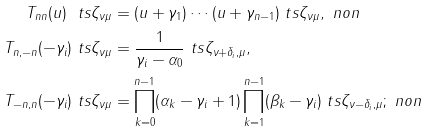Convert formula to latex. <formula><loc_0><loc_0><loc_500><loc_500>T _ { n n } ( u ) \ t s \zeta _ { \nu \mu } & = ( u + \gamma _ { 1 } ) \cdots ( u + \gamma _ { n - 1 } ) \ t s \zeta _ { \nu \mu } , \ n o n \\ T _ { n , - n } ( - \gamma _ { i } ) \ t s \zeta _ { \nu \mu } & = \frac { 1 } { \gamma _ { i } - \alpha _ { 0 } } \ t s \zeta _ { \nu + \delta _ { i } , \mu } , \\ T _ { - n , n } ( - \gamma _ { i } ) \ t s \zeta _ { \nu \mu } & = \prod _ { k = 0 } ^ { n - 1 } ( \alpha _ { k } - \gamma _ { i } + 1 ) \prod _ { k = 1 } ^ { n - 1 } ( \beta _ { k } - \gamma _ { i } ) \ t s \zeta _ { \nu - \delta _ { i } , \mu } ; \ n o n</formula> 